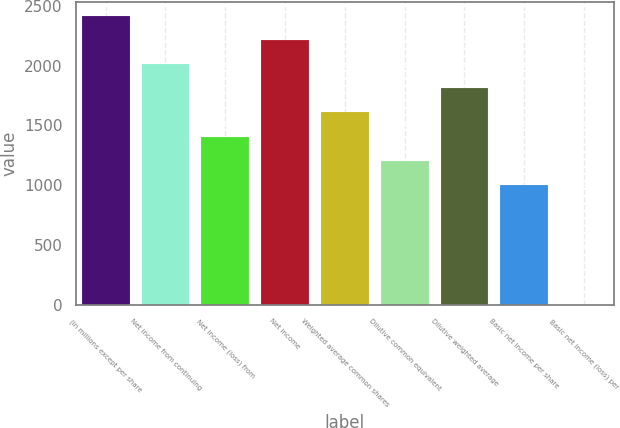<chart> <loc_0><loc_0><loc_500><loc_500><bar_chart><fcel>(In millions except per share<fcel>Net income from continuing<fcel>Net income (loss) from<fcel>Net income<fcel>Weighted average common shares<fcel>Dilutive common equivalent<fcel>Dilutive weighted average<fcel>Basic net income per share<fcel>Basic net income (loss) per<nl><fcel>2412.03<fcel>2010.03<fcel>1407.03<fcel>2211.03<fcel>1608.03<fcel>1206.03<fcel>1809.03<fcel>1005.03<fcel>0.03<nl></chart> 